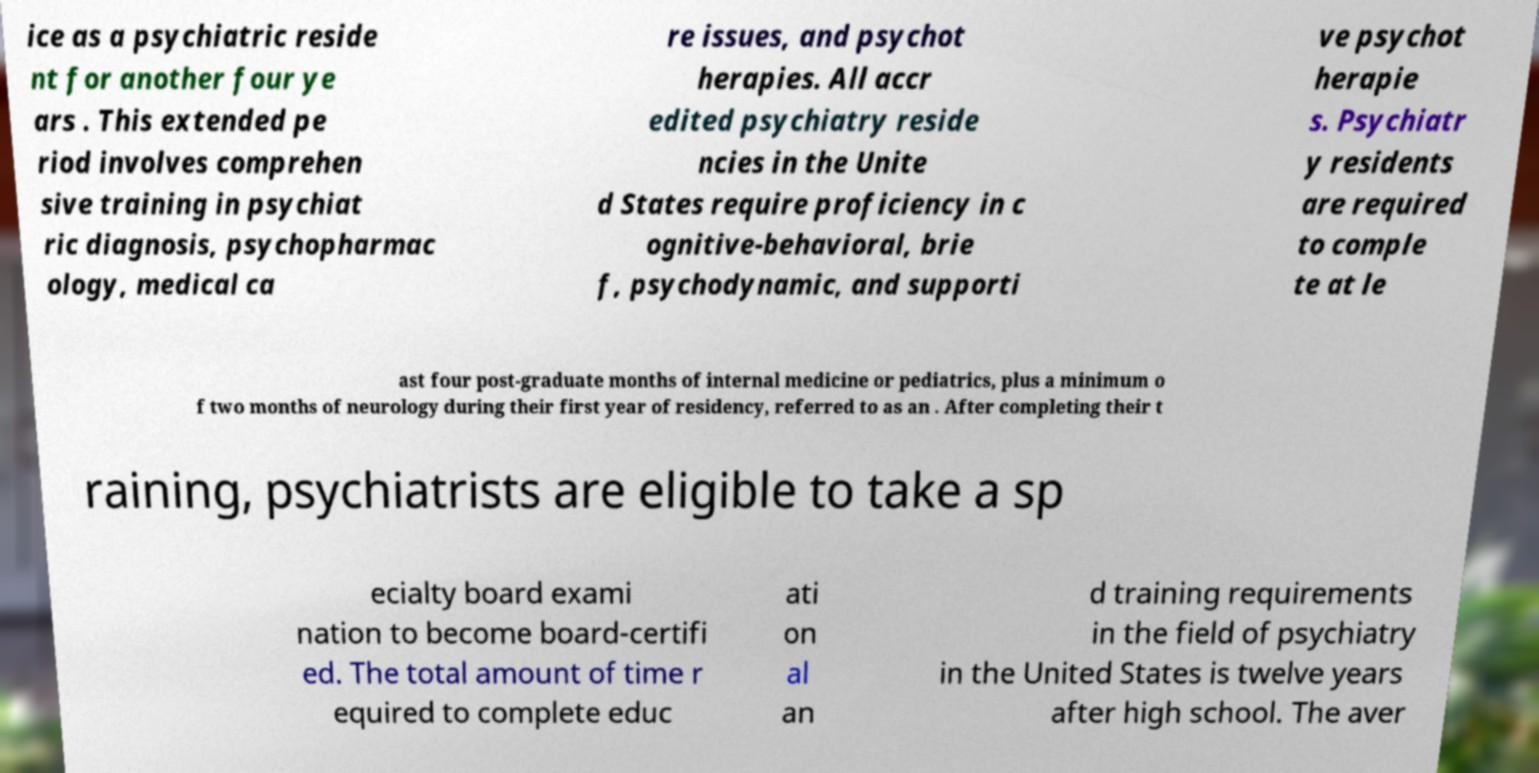Could you extract and type out the text from this image? ice as a psychiatric reside nt for another four ye ars . This extended pe riod involves comprehen sive training in psychiat ric diagnosis, psychopharmac ology, medical ca re issues, and psychot herapies. All accr edited psychiatry reside ncies in the Unite d States require proficiency in c ognitive-behavioral, brie f, psychodynamic, and supporti ve psychot herapie s. Psychiatr y residents are required to comple te at le ast four post-graduate months of internal medicine or pediatrics, plus a minimum o f two months of neurology during their first year of residency, referred to as an . After completing their t raining, psychiatrists are eligible to take a sp ecialty board exami nation to become board-certifi ed. The total amount of time r equired to complete educ ati on al an d training requirements in the field of psychiatry in the United States is twelve years after high school. The aver 